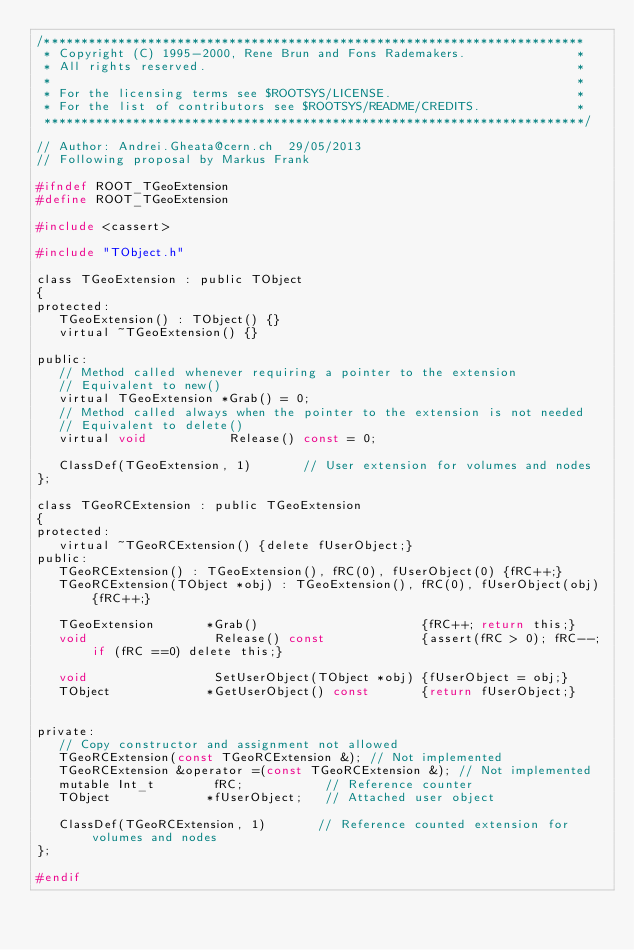<code> <loc_0><loc_0><loc_500><loc_500><_C_>/*************************************************************************
 * Copyright (C) 1995-2000, Rene Brun and Fons Rademakers.               *
 * All rights reserved.                                                  *
 *                                                                       *
 * For the licensing terms see $ROOTSYS/LICENSE.                         *
 * For the list of contributors see $ROOTSYS/README/CREDITS.             *
 *************************************************************************/

// Author: Andrei.Gheata@cern.ch  29/05/2013
// Following proposal by Markus Frank

#ifndef ROOT_TGeoExtension
#define ROOT_TGeoExtension

#include <cassert>

#include "TObject.h"

class TGeoExtension : public TObject
{
protected:
   TGeoExtension() : TObject() {}
   virtual ~TGeoExtension() {}

public:
   // Method called whenever requiring a pointer to the extension
   // Equivalent to new()
   virtual TGeoExtension *Grab() = 0;
   // Method called always when the pointer to the extension is not needed
   // Equivalent to delete()
   virtual void           Release() const = 0;

   ClassDef(TGeoExtension, 1)       // User extension for volumes and nodes
};

class TGeoRCExtension : public TGeoExtension
{
protected:
   virtual ~TGeoRCExtension() {delete fUserObject;}
public:
   TGeoRCExtension() : TGeoExtension(), fRC(0), fUserObject(0) {fRC++;}
   TGeoRCExtension(TObject *obj) : TGeoExtension(), fRC(0), fUserObject(obj) {fRC++;}

   TGeoExtension       *Grab()                      {fRC++; return this;}
   void                 Release() const             {assert(fRC > 0); fRC--; if (fRC ==0) delete this;}

   void                 SetUserObject(TObject *obj) {fUserObject = obj;}
   TObject             *GetUserObject() const       {return fUserObject;}


private:
   // Copy constructor and assignment not allowed
   TGeoRCExtension(const TGeoRCExtension &); // Not implemented
   TGeoRCExtension &operator =(const TGeoRCExtension &); // Not implemented
   mutable Int_t        fRC;           // Reference counter
   TObject             *fUserObject;   // Attached user object

   ClassDef(TGeoRCExtension, 1)       // Reference counted extension for volumes and nodes
};

#endif
</code> 